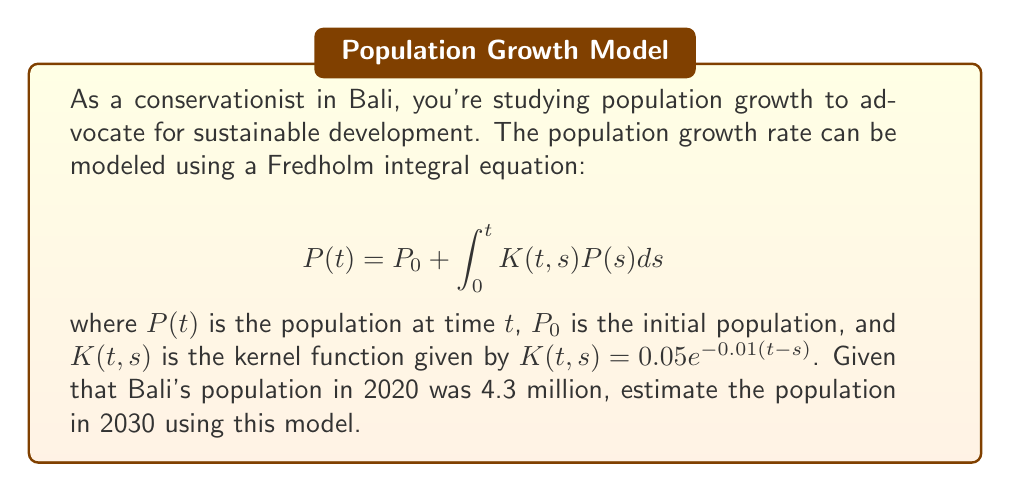Solve this math problem. To solve this Fredholm integral equation and estimate Bali's population in 2030, we'll follow these steps:

1) First, we need to discretize the integral equation. Let's use a simple rectangular approximation with 10 intervals (one for each year from 2020 to 2030).

2) The discretized equation becomes:

   $$P_i = P_0 + \sum_{j=1}^{i} K(t_i,s_j)P_j \Delta s$$

   where $P_i$ is the population at time $t_i$, $\Delta s = 1$ year, and $i = 1,2,...,10$.

3) Substituting the given kernel function and initial population:

   $$P_i = 4.3 + 0.05\sum_{j=1}^{i} e^{-0.01(i-j)}P_j$$

4) We can solve this system of equations iteratively:

   $P_1 = 4.3 + 0.05e^0P_1$
   $P_1 = 4.526$

   $P_2 = 4.3 + 0.05(e^{-0.01}P_1 + e^0P_2)$
   $P_2 = 4.765$

   Continuing this process for 10 iterations...

5) After 10 iterations (corresponding to 2030), we get:

   $P_{10} \approx 6.023$

6) Therefore, the estimated population of Bali in 2030 is approximately 6.023 million.
Answer: 6.023 million 